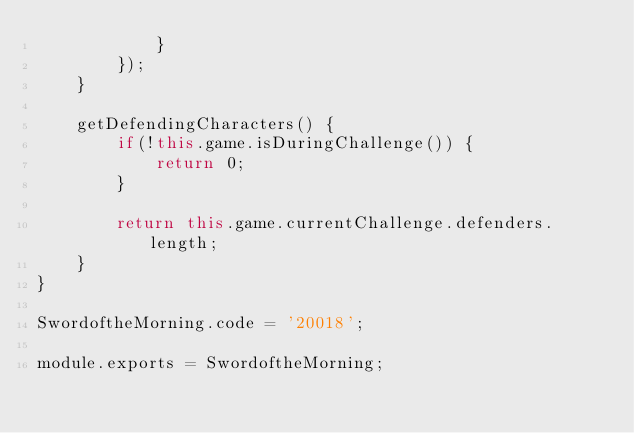Convert code to text. <code><loc_0><loc_0><loc_500><loc_500><_JavaScript_>            }
        });
    }

    getDefendingCharacters() {
        if(!this.game.isDuringChallenge()) {
            return 0;
        }

        return this.game.currentChallenge.defenders.length;
    }
}

SwordoftheMorning.code = '20018';

module.exports = SwordoftheMorning;
</code> 